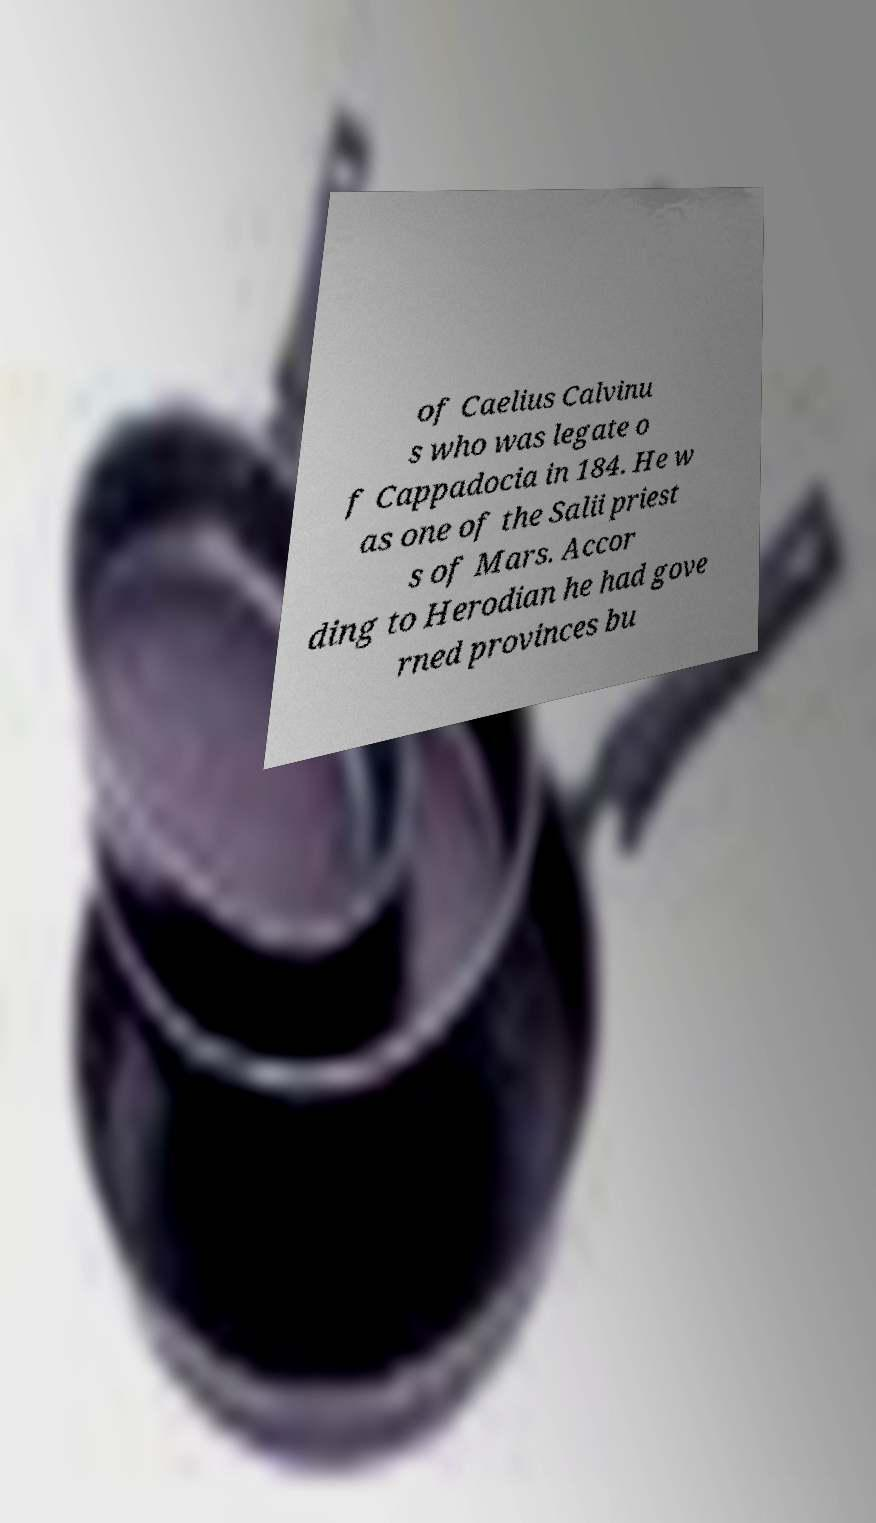Could you assist in decoding the text presented in this image and type it out clearly? of Caelius Calvinu s who was legate o f Cappadocia in 184. He w as one of the Salii priest s of Mars. Accor ding to Herodian he had gove rned provinces bu 